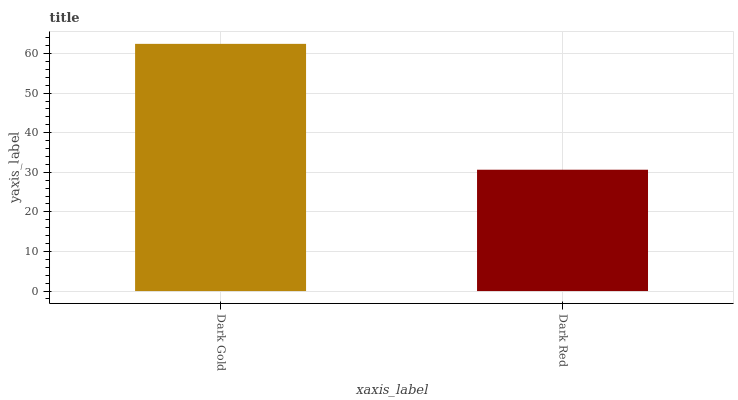Is Dark Red the minimum?
Answer yes or no. Yes. Is Dark Gold the maximum?
Answer yes or no. Yes. Is Dark Red the maximum?
Answer yes or no. No. Is Dark Gold greater than Dark Red?
Answer yes or no. Yes. Is Dark Red less than Dark Gold?
Answer yes or no. Yes. Is Dark Red greater than Dark Gold?
Answer yes or no. No. Is Dark Gold less than Dark Red?
Answer yes or no. No. Is Dark Gold the high median?
Answer yes or no. Yes. Is Dark Red the low median?
Answer yes or no. Yes. Is Dark Red the high median?
Answer yes or no. No. Is Dark Gold the low median?
Answer yes or no. No. 